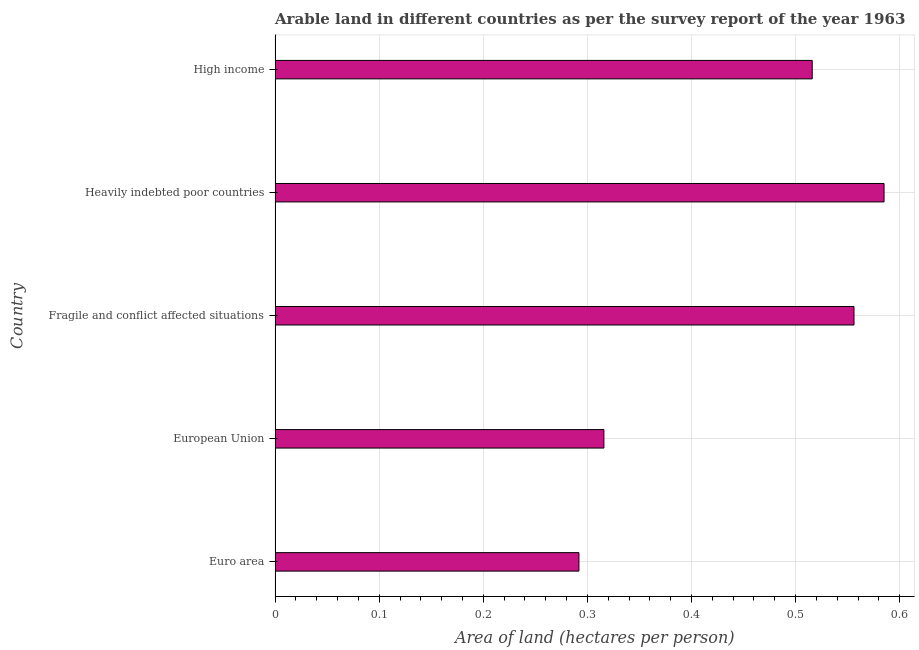Does the graph contain any zero values?
Your answer should be very brief. No. Does the graph contain grids?
Offer a very short reply. Yes. What is the title of the graph?
Give a very brief answer. Arable land in different countries as per the survey report of the year 1963. What is the label or title of the X-axis?
Offer a very short reply. Area of land (hectares per person). What is the area of arable land in Heavily indebted poor countries?
Offer a very short reply. 0.58. Across all countries, what is the maximum area of arable land?
Offer a very short reply. 0.58. Across all countries, what is the minimum area of arable land?
Keep it short and to the point. 0.29. In which country was the area of arable land maximum?
Your answer should be compact. Heavily indebted poor countries. What is the sum of the area of arable land?
Your answer should be very brief. 2.26. What is the difference between the area of arable land in Fragile and conflict affected situations and Heavily indebted poor countries?
Offer a terse response. -0.03. What is the average area of arable land per country?
Your answer should be very brief. 0.45. What is the median area of arable land?
Offer a very short reply. 0.52. In how many countries, is the area of arable land greater than 0.18 hectares per person?
Provide a short and direct response. 5. What is the ratio of the area of arable land in Euro area to that in High income?
Keep it short and to the point. 0.57. Is the area of arable land in Euro area less than that in European Union?
Your response must be concise. Yes. What is the difference between the highest and the second highest area of arable land?
Your answer should be compact. 0.03. What is the difference between the highest and the lowest area of arable land?
Provide a short and direct response. 0.29. In how many countries, is the area of arable land greater than the average area of arable land taken over all countries?
Provide a succinct answer. 3. How many bars are there?
Give a very brief answer. 5. Are all the bars in the graph horizontal?
Ensure brevity in your answer.  Yes. How many countries are there in the graph?
Provide a short and direct response. 5. What is the difference between two consecutive major ticks on the X-axis?
Offer a very short reply. 0.1. What is the Area of land (hectares per person) in Euro area?
Provide a short and direct response. 0.29. What is the Area of land (hectares per person) in European Union?
Provide a succinct answer. 0.32. What is the Area of land (hectares per person) in Fragile and conflict affected situations?
Keep it short and to the point. 0.56. What is the Area of land (hectares per person) in Heavily indebted poor countries?
Your answer should be compact. 0.58. What is the Area of land (hectares per person) of High income?
Provide a short and direct response. 0.52. What is the difference between the Area of land (hectares per person) in Euro area and European Union?
Your answer should be compact. -0.02. What is the difference between the Area of land (hectares per person) in Euro area and Fragile and conflict affected situations?
Offer a terse response. -0.26. What is the difference between the Area of land (hectares per person) in Euro area and Heavily indebted poor countries?
Offer a terse response. -0.29. What is the difference between the Area of land (hectares per person) in Euro area and High income?
Provide a short and direct response. -0.22. What is the difference between the Area of land (hectares per person) in European Union and Fragile and conflict affected situations?
Keep it short and to the point. -0.24. What is the difference between the Area of land (hectares per person) in European Union and Heavily indebted poor countries?
Offer a very short reply. -0.27. What is the difference between the Area of land (hectares per person) in European Union and High income?
Your response must be concise. -0.2. What is the difference between the Area of land (hectares per person) in Fragile and conflict affected situations and Heavily indebted poor countries?
Ensure brevity in your answer.  -0.03. What is the difference between the Area of land (hectares per person) in Fragile and conflict affected situations and High income?
Offer a terse response. 0.04. What is the difference between the Area of land (hectares per person) in Heavily indebted poor countries and High income?
Offer a terse response. 0.07. What is the ratio of the Area of land (hectares per person) in Euro area to that in European Union?
Your answer should be compact. 0.92. What is the ratio of the Area of land (hectares per person) in Euro area to that in Fragile and conflict affected situations?
Ensure brevity in your answer.  0.53. What is the ratio of the Area of land (hectares per person) in Euro area to that in Heavily indebted poor countries?
Your response must be concise. 0.5. What is the ratio of the Area of land (hectares per person) in Euro area to that in High income?
Ensure brevity in your answer.  0.57. What is the ratio of the Area of land (hectares per person) in European Union to that in Fragile and conflict affected situations?
Ensure brevity in your answer.  0.57. What is the ratio of the Area of land (hectares per person) in European Union to that in Heavily indebted poor countries?
Your answer should be very brief. 0.54. What is the ratio of the Area of land (hectares per person) in European Union to that in High income?
Make the answer very short. 0.61. What is the ratio of the Area of land (hectares per person) in Fragile and conflict affected situations to that in Heavily indebted poor countries?
Make the answer very short. 0.95. What is the ratio of the Area of land (hectares per person) in Fragile and conflict affected situations to that in High income?
Keep it short and to the point. 1.08. What is the ratio of the Area of land (hectares per person) in Heavily indebted poor countries to that in High income?
Offer a very short reply. 1.13. 